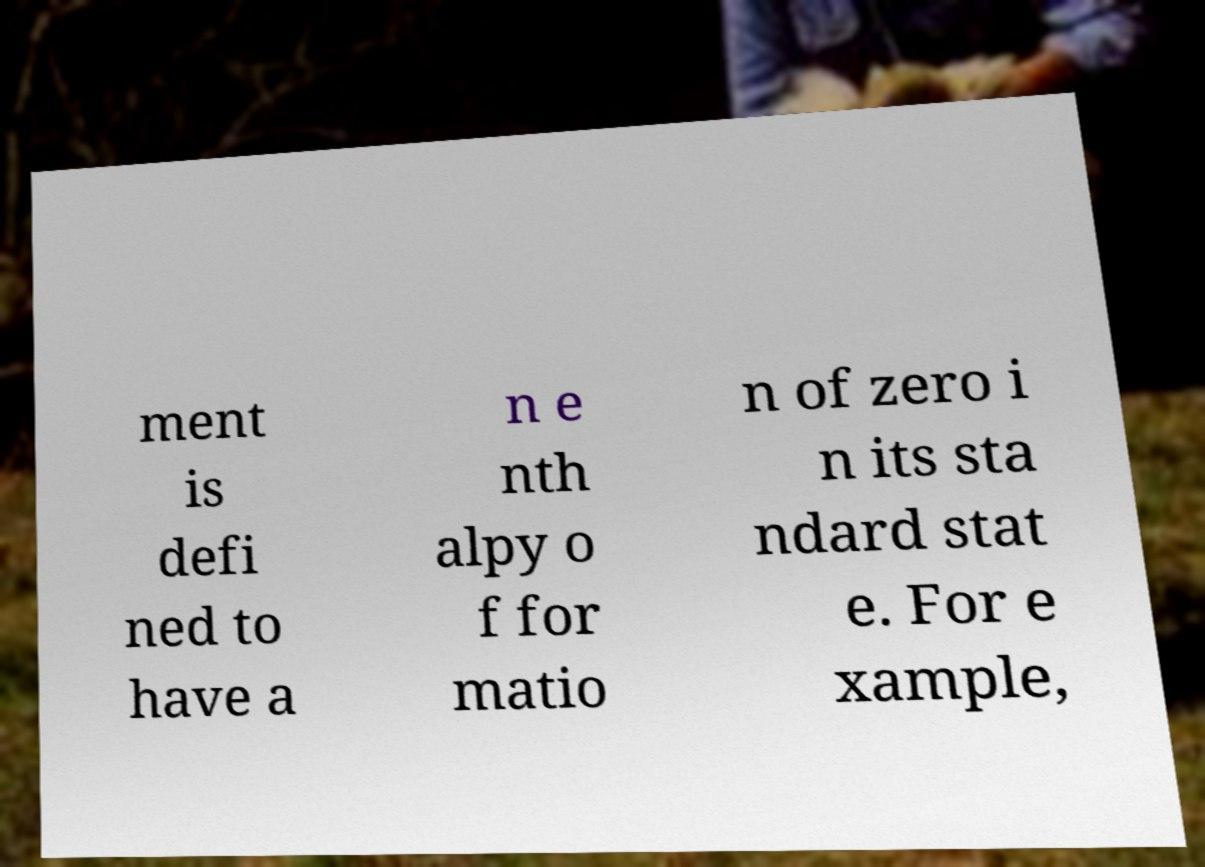I need the written content from this picture converted into text. Can you do that? ment is defi ned to have a n e nth alpy o f for matio n of zero i n its sta ndard stat e. For e xample, 